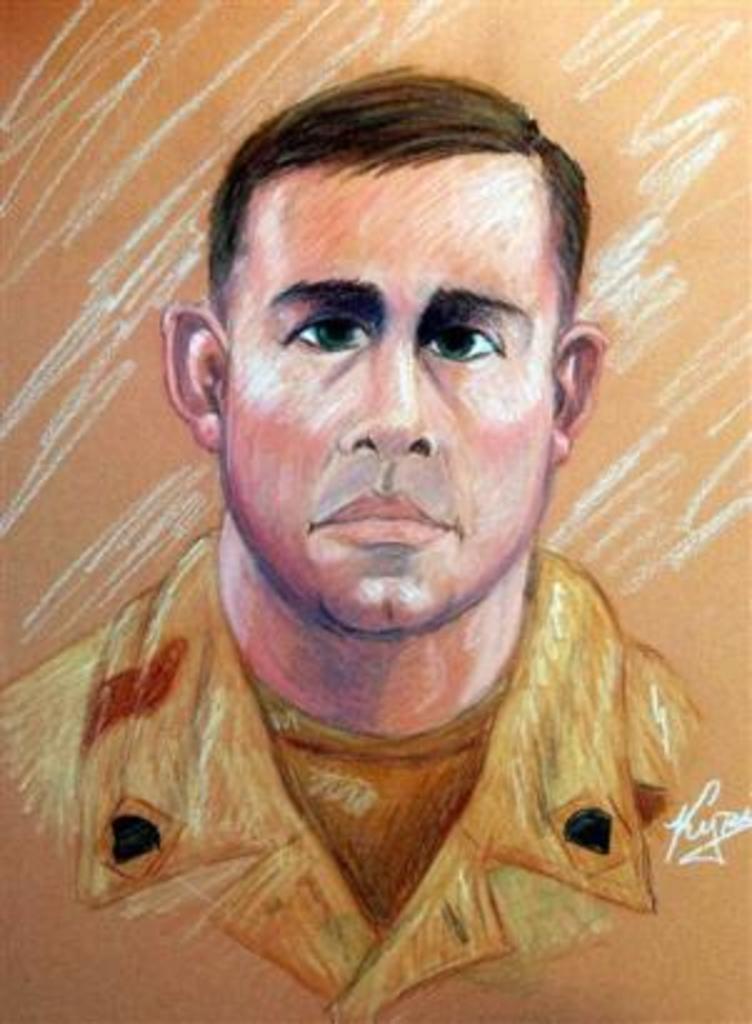How would you summarize this image in a sentence or two? This is a painting. In this image there is a painting of a person and at the bottom right there is a text. 